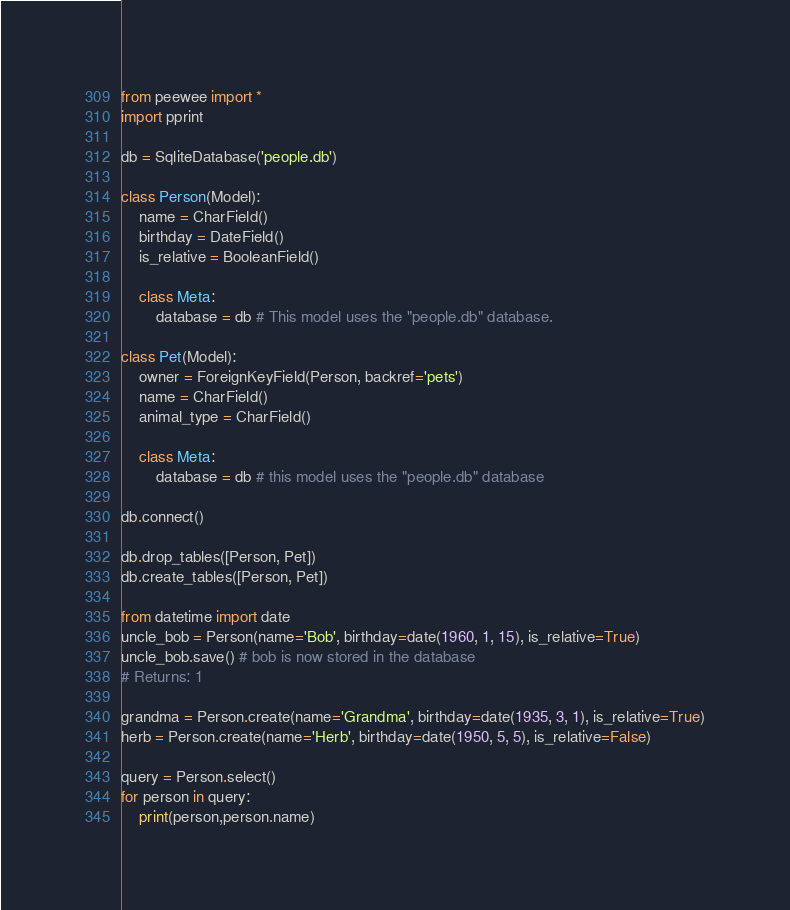<code> <loc_0><loc_0><loc_500><loc_500><_Python_>from peewee import *
import pprint

db = SqliteDatabase('people.db')

class Person(Model):
    name = CharField()
    birthday = DateField()
    is_relative = BooleanField()

    class Meta:
        database = db # This model uses the "people.db" database.

class Pet(Model):
    owner = ForeignKeyField(Person, backref='pets')
    name = CharField()
    animal_type = CharField()

    class Meta:
        database = db # this model uses the "people.db" database

db.connect()

db.drop_tables([Person, Pet])
db.create_tables([Person, Pet])

from datetime import date
uncle_bob = Person(name='Bob', birthday=date(1960, 1, 15), is_relative=True)
uncle_bob.save() # bob is now stored in the database
# Returns: 1

grandma = Person.create(name='Grandma', birthday=date(1935, 3, 1), is_relative=True)
herb = Person.create(name='Herb', birthday=date(1950, 5, 5), is_relative=False)

query = Person.select()
for person in query:
    print(person,person.name)

</code> 